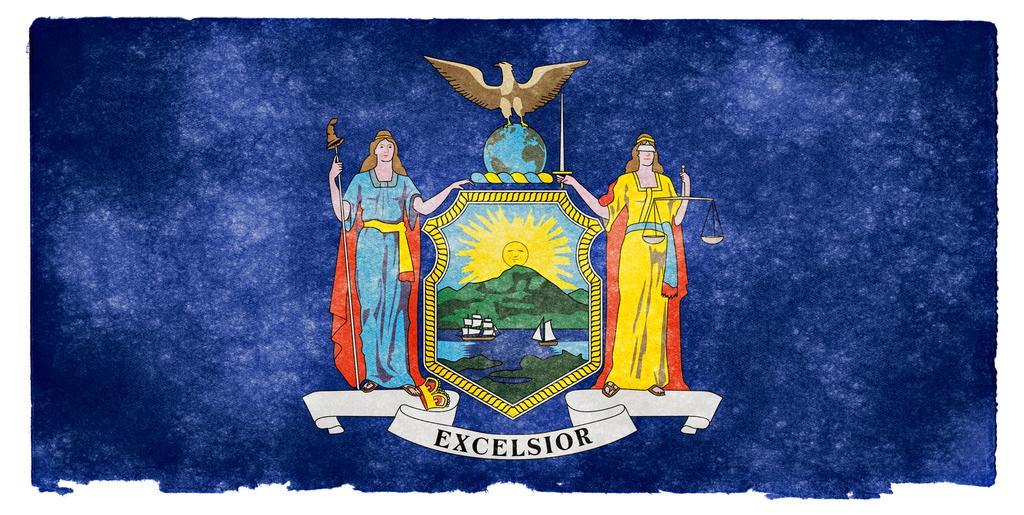Describe this image in one or two sentences. In this image there is a painting. Middle of the image there is an emblem having boats in water. Behind there are hills. Behind it there is a sun. Top of it there is a bird standing on the globe. On both sides of the emblem persons are standing. Bottom of the image there is some text. Background is in blue color. 